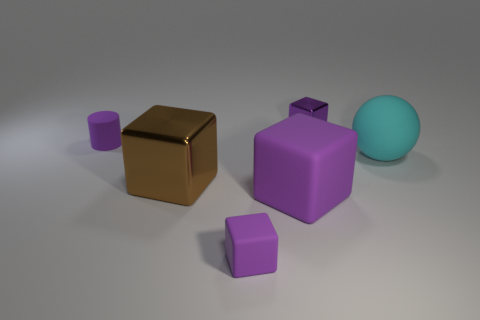There is a shiny cube that is behind the tiny purple matte thing behind the big metal thing; are there any small purple rubber cubes behind it?
Offer a terse response. No. There is a purple shiny block; are there any cubes behind it?
Offer a terse response. No. There is a metallic object that is in front of the tiny metallic object; how many large blocks are left of it?
Give a very brief answer. 0. Is the size of the purple cylinder the same as the metallic thing behind the cyan rubber ball?
Ensure brevity in your answer.  Yes. Are there any things that have the same color as the rubber ball?
Your response must be concise. No. There is a cyan thing that is made of the same material as the small purple cylinder; what is its size?
Provide a short and direct response. Large. Does the large brown block have the same material as the large purple thing?
Your response must be concise. No. What is the color of the large rubber thing to the left of the big cyan sphere that is behind the metallic thing that is on the left side of the big purple matte block?
Offer a very short reply. Purple. The cyan rubber object is what shape?
Keep it short and to the point. Sphere. There is a ball; is it the same color as the thing that is behind the purple matte cylinder?
Your response must be concise. No. 